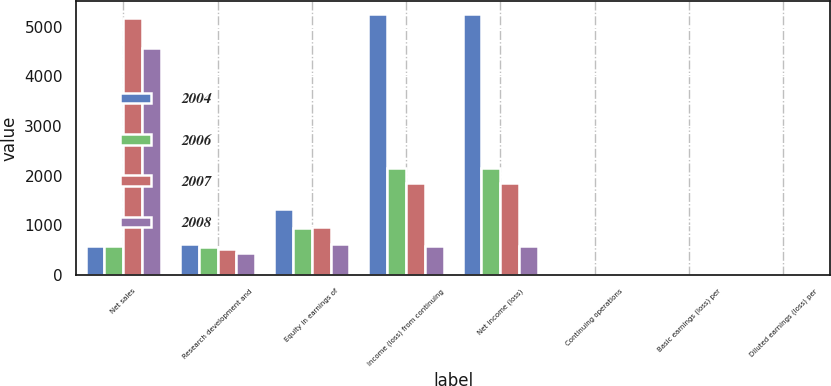Convert chart. <chart><loc_0><loc_0><loc_500><loc_500><stacked_bar_chart><ecel><fcel>Net sales<fcel>Research development and<fcel>Equity in earnings of<fcel>Income (loss) from continuing<fcel>Net income (loss)<fcel>Continuing operations<fcel>Basic earnings (loss) per<fcel>Diluted earnings (loss) per<nl><fcel>2004<fcel>575<fcel>627<fcel>1328<fcel>5257<fcel>5257<fcel>3.37<fcel>3.37<fcel>3.32<nl><fcel>2006<fcel>575<fcel>565<fcel>942<fcel>2150<fcel>2150<fcel>1.37<fcel>1.37<fcel>1.34<nl><fcel>2007<fcel>5174<fcel>517<fcel>960<fcel>1855<fcel>1855<fcel>1.2<fcel>1.2<fcel>1.16<nl><fcel>2008<fcel>4579<fcel>443<fcel>611<fcel>585<fcel>585<fcel>0.4<fcel>0.4<fcel>0.38<nl></chart> 